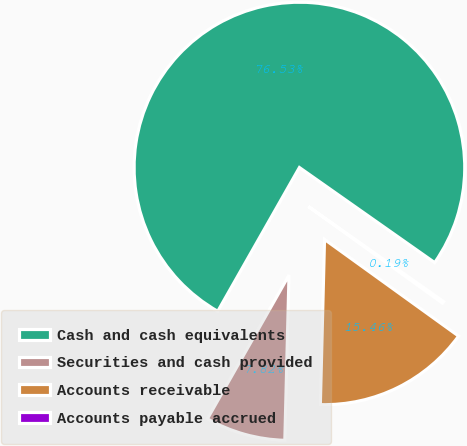Convert chart. <chart><loc_0><loc_0><loc_500><loc_500><pie_chart><fcel>Cash and cash equivalents<fcel>Securities and cash provided<fcel>Accounts receivable<fcel>Accounts payable accrued<nl><fcel>76.53%<fcel>7.82%<fcel>15.46%<fcel>0.19%<nl></chart> 